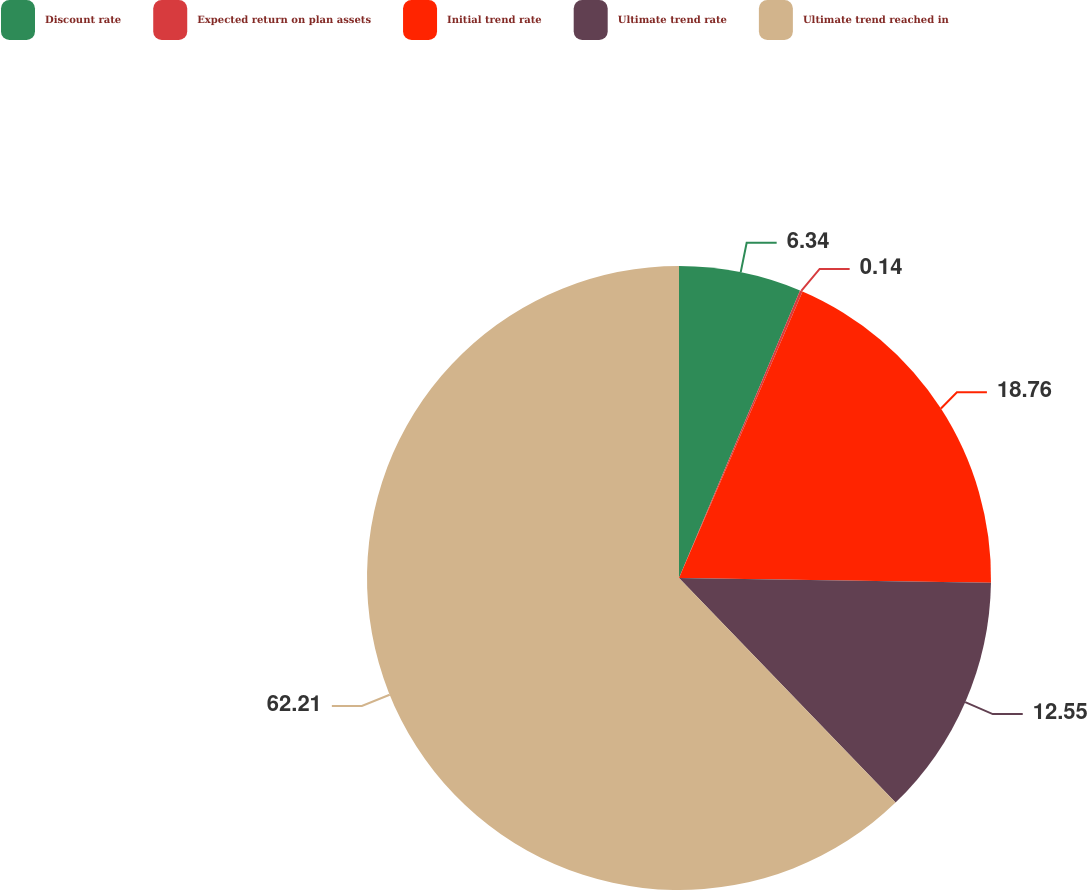Convert chart to OTSL. <chart><loc_0><loc_0><loc_500><loc_500><pie_chart><fcel>Discount rate<fcel>Expected return on plan assets<fcel>Initial trend rate<fcel>Ultimate trend rate<fcel>Ultimate trend reached in<nl><fcel>6.34%<fcel>0.14%<fcel>18.76%<fcel>12.55%<fcel>62.21%<nl></chart> 